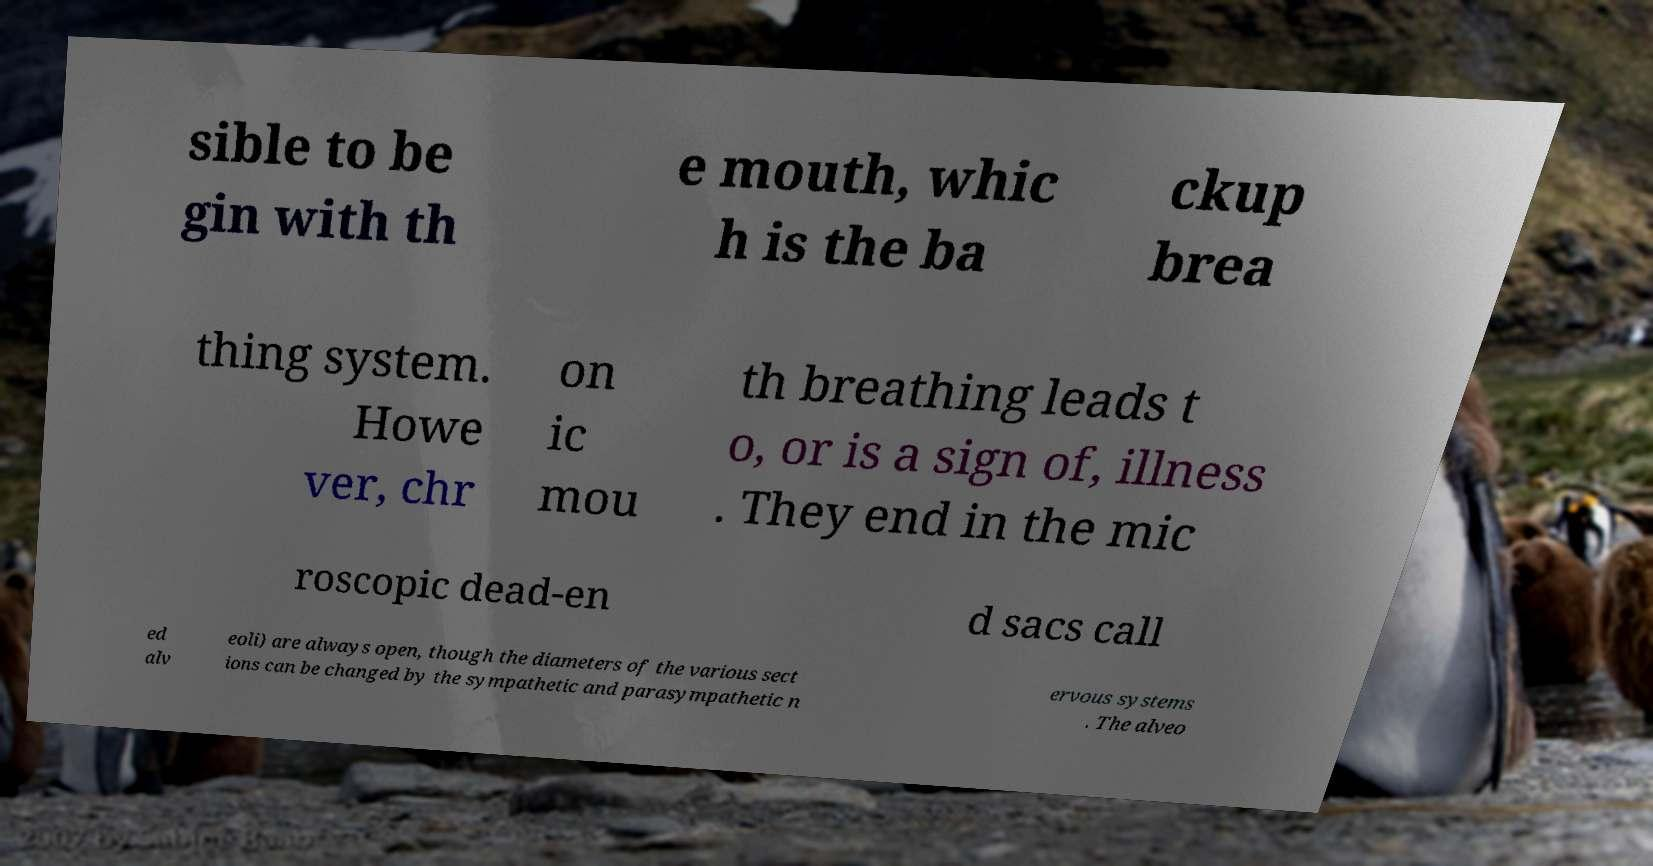Please read and relay the text visible in this image. What does it say? sible to be gin with th e mouth, whic h is the ba ckup brea thing system. Howe ver, chr on ic mou th breathing leads t o, or is a sign of, illness . They end in the mic roscopic dead-en d sacs call ed alv eoli) are always open, though the diameters of the various sect ions can be changed by the sympathetic and parasympathetic n ervous systems . The alveo 